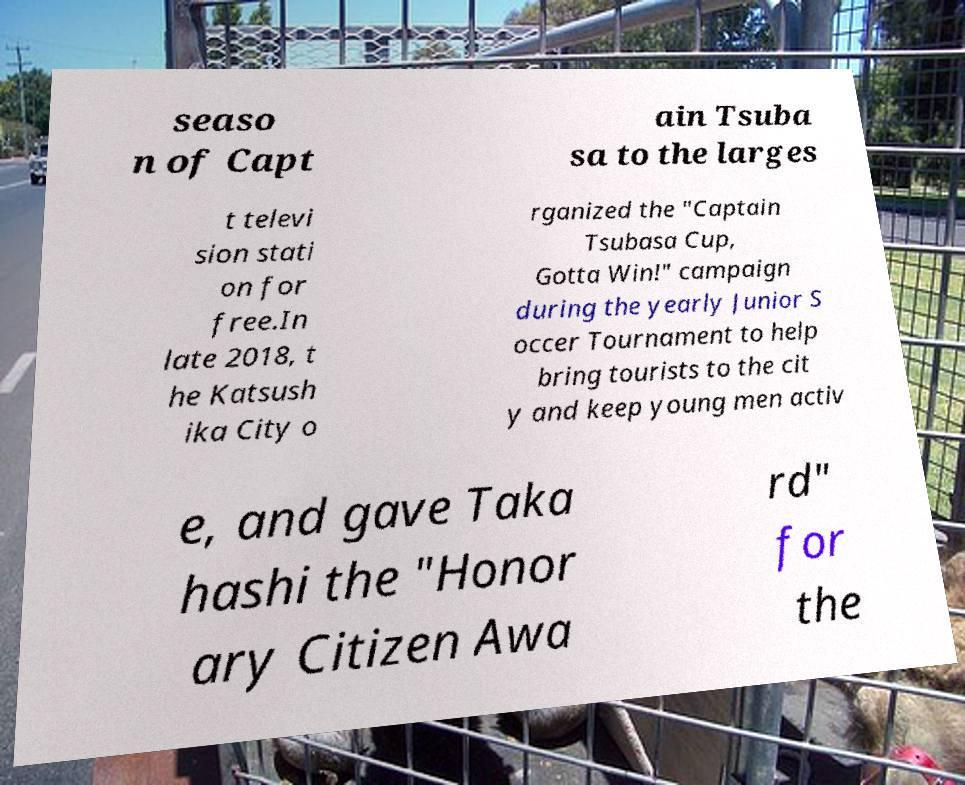Could you assist in decoding the text presented in this image and type it out clearly? seaso n of Capt ain Tsuba sa to the larges t televi sion stati on for free.In late 2018, t he Katsush ika City o rganized the "Captain Tsubasa Cup, Gotta Win!" campaign during the yearly Junior S occer Tournament to help bring tourists to the cit y and keep young men activ e, and gave Taka hashi the "Honor ary Citizen Awa rd" for the 